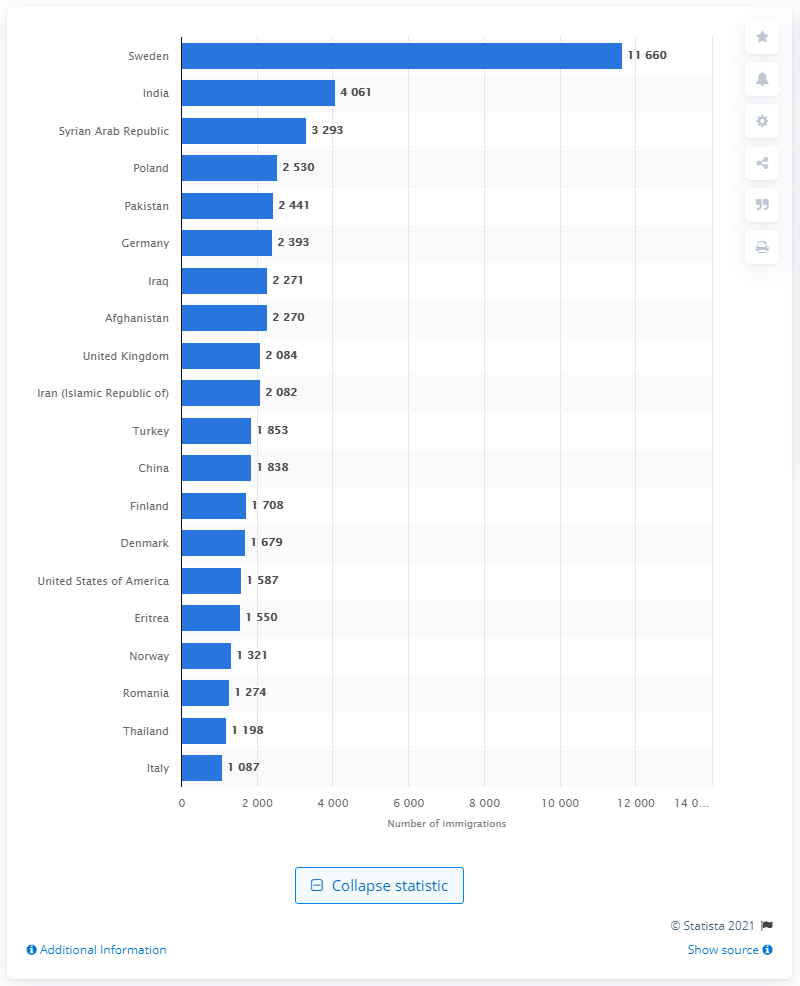List a handful of essential elements in this visual. In 2020, the majority of immigrants chose to move to Sweden. 